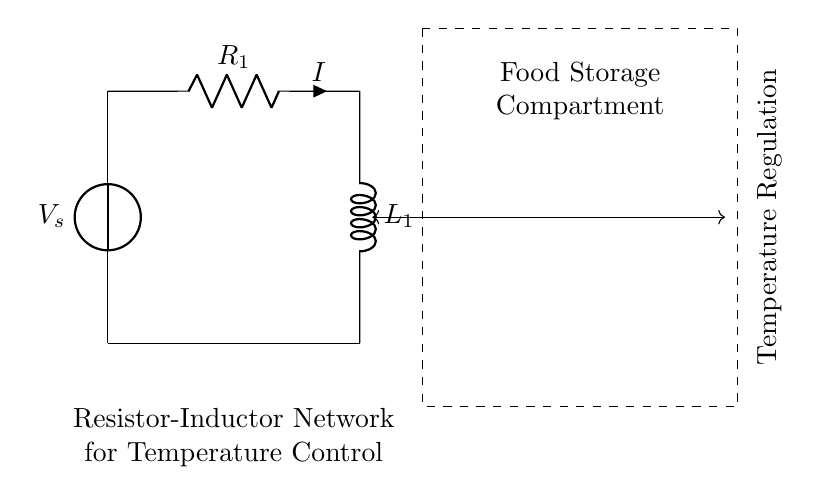What components are in this circuit? The diagram shows a voltage source, a resistor, and an inductor. These three components are essential for the operation of the resistor-inductor network.
Answer: voltage source, resistor, inductor What is the current flowing through the resistor? The current in the circuit is represented as 'I' next to the resistor symbol, indicating it is the same current that flows through the entire series circuit.
Answer: I What type of circuit is depicted? The circuit is a resistor-inductor network, which indicates a series connection of a resistor and an inductor within the entire circuit context.
Answer: resistor-inductor How does this circuit contribute to temperature regulation? The resistor-inductor network is used to manage current flow, which can affect the temperature in the food storage compartment by controlling power delivery to any connected heating or cooling systems.
Answer: managing current flow What is the purpose of the inductor in this circuit? The inductor stores energy in its magnetic field and helps in smoothing out the current change, which stabilizes the temperature in the food storage compartment by providing a more consistent current flow.
Answer: stores energy What would happen if the resistance is increased? Increasing resistance will decrease the current in the circuit, due to Ohm's law, which might lead to less power delivered to the heating or cooling systems, potentially affecting temperature control.
Answer: less current What is being regulated in the food storage compartment? The diagram illustrates that temperature regulation is the main focus, as it's annotated clearly within the dashed rectangle surrounding the specific components.
Answer: temperature 